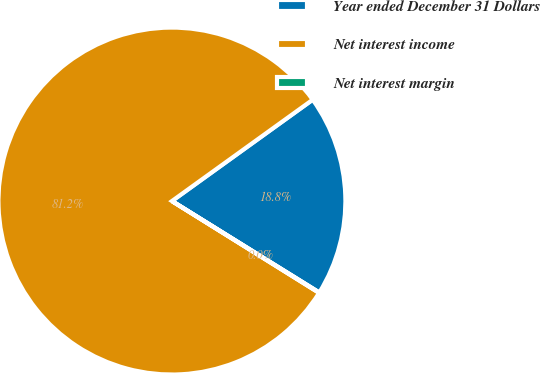<chart> <loc_0><loc_0><loc_500><loc_500><pie_chart><fcel>Year ended December 31 Dollars<fcel>Net interest income<fcel>Net interest margin<nl><fcel>18.77%<fcel>81.2%<fcel>0.04%<nl></chart> 